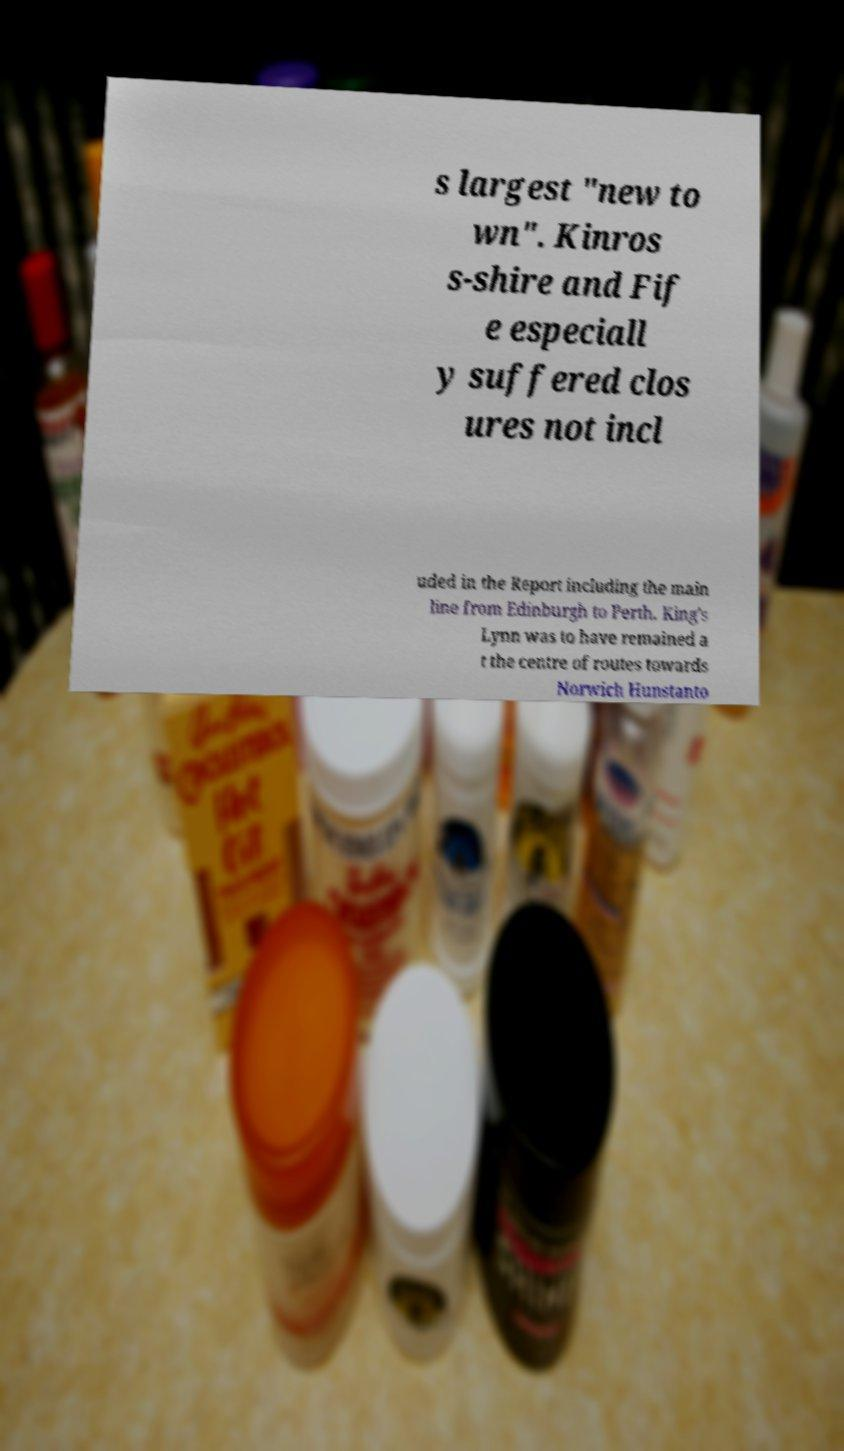I need the written content from this picture converted into text. Can you do that? s largest "new to wn". Kinros s-shire and Fif e especiall y suffered clos ures not incl uded in the Report including the main line from Edinburgh to Perth. King's Lynn was to have remained a t the centre of routes towards Norwich Hunstanto 